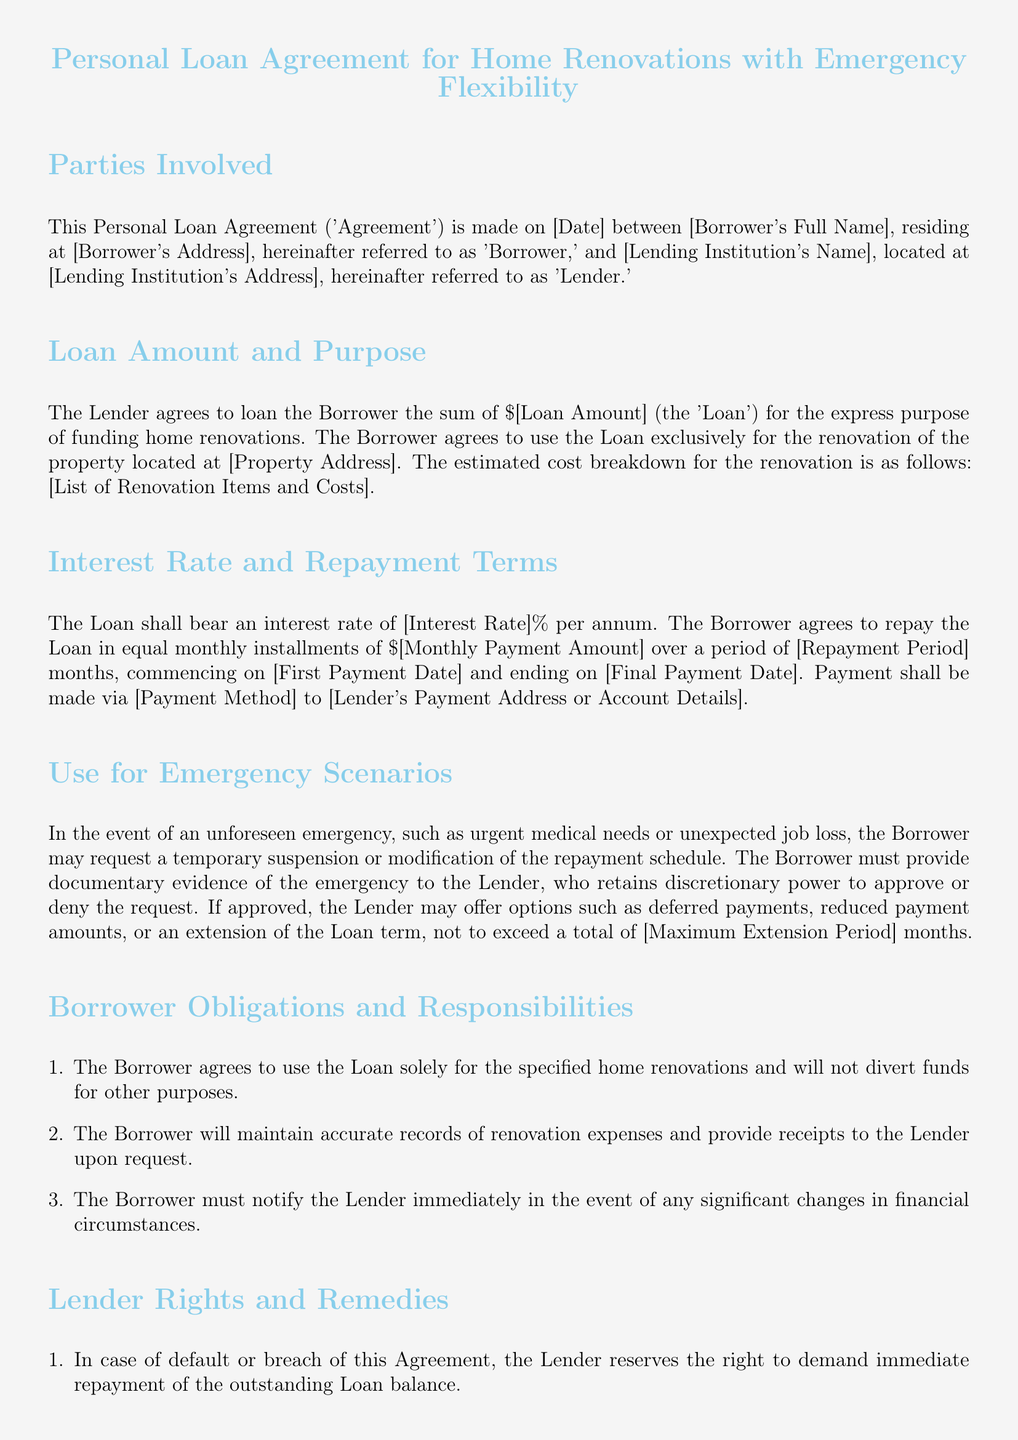what is the loan amount? The loan amount is specified in the document as \$[Loan Amount].
Answer: \$[Loan Amount] what is the interest rate? The interest rate is indicated as [Interest Rate]% per annum.
Answer: [Interest Rate]% what is the repayment period in months? The repayment period is detailed as [Repayment Period] months in the document.
Answer: [Repayment Period] months what are the possible reasons for requesting a loan modification? The document mentions unforeseen emergencies like urgent medical needs or unexpected job loss as reasons for requesting modification.
Answer: Urgent medical needs or unexpected job loss what must the borrower provide to request a temporary suspension of payments? The Borrower must provide documentary evidence of the emergency to the Lender.
Answer: Documentary evidence of the emergency what is the maximum extension period for loan repayment? The document specifies a maximum extension period not to exceed [Maximum Extension Period] months.
Answer: [Maximum Extension Period] months who retains the right to demand immediate repayment in case of default? The Lender reserves the right to demand immediate repayment of the outstanding Loan balance.
Answer: The Lender what happens if a payment is overdue? The Lender may impose late fees amounting to [Late Fee Amount].
Answer: [Late Fee Amount] how must modifications to the agreement be made? Modifications must be made in writing and signed by both parties.
Answer: In writing and signed by both parties 